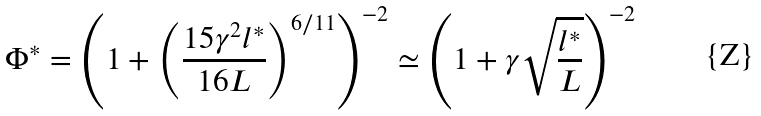Convert formula to latex. <formula><loc_0><loc_0><loc_500><loc_500>\Phi ^ { * } = \left ( 1 + \left ( \frac { 1 5 \gamma ^ { 2 } l ^ { * } } { 1 6 L } \right ) ^ { 6 / 1 1 } \right ) ^ { - 2 } \simeq \left ( 1 + \gamma \sqrt { \frac { l ^ { * } } { L } } \right ) ^ { - 2 }</formula> 